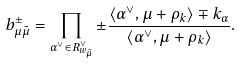<formula> <loc_0><loc_0><loc_500><loc_500>b _ { \mu \tilde { \mu } } ^ { \pm } = \prod _ { \alpha ^ { \vee } \in R _ { w _ { \tilde { \mu } } } ^ { \vee } } \pm \frac { \langle \alpha ^ { \vee } , \mu + \rho _ { k } \rangle \mp k _ { \alpha } } { \langle \alpha ^ { \vee } , \mu + \rho _ { k } \rangle } .</formula> 